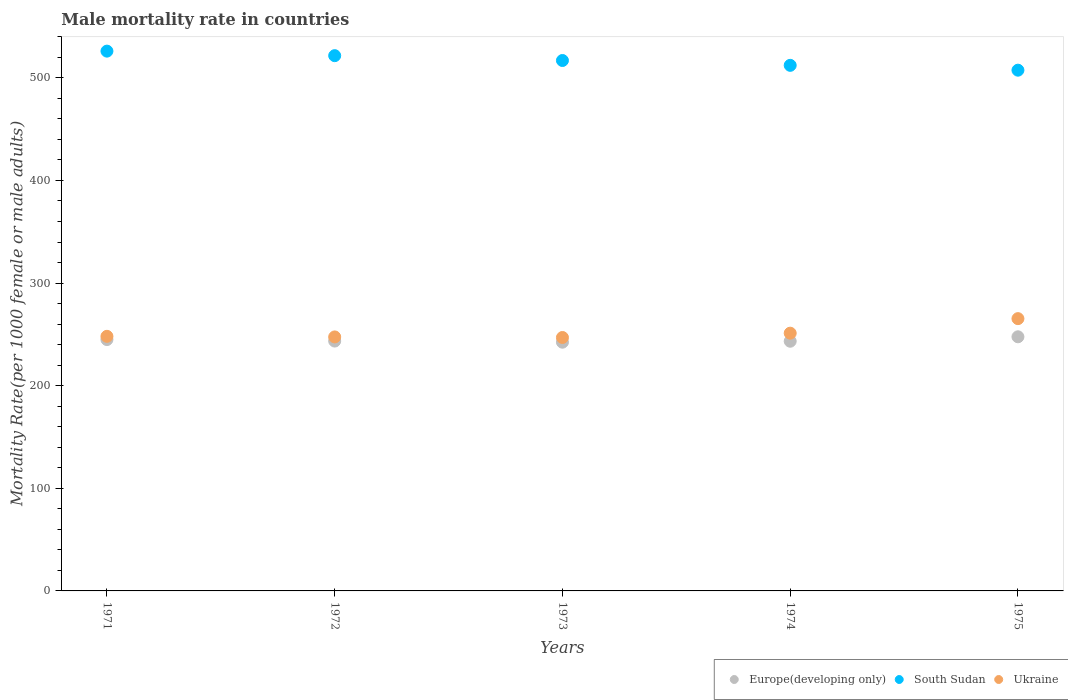How many different coloured dotlines are there?
Ensure brevity in your answer.  3. What is the male mortality rate in Ukraine in 1972?
Your response must be concise. 247.51. Across all years, what is the maximum male mortality rate in Europe(developing only)?
Your answer should be very brief. 247.64. Across all years, what is the minimum male mortality rate in South Sudan?
Provide a short and direct response. 507.44. In which year was the male mortality rate in Europe(developing only) maximum?
Offer a terse response. 1975. In which year was the male mortality rate in South Sudan minimum?
Ensure brevity in your answer.  1975. What is the total male mortality rate in Ukraine in the graph?
Offer a very short reply. 1259.04. What is the difference between the male mortality rate in Europe(developing only) in 1971 and that in 1972?
Your answer should be very brief. 1.46. What is the difference between the male mortality rate in Europe(developing only) in 1975 and the male mortality rate in Ukraine in 1974?
Offer a very short reply. -3.52. What is the average male mortality rate in Europe(developing only) per year?
Your answer should be compact. 244.35. In the year 1971, what is the difference between the male mortality rate in South Sudan and male mortality rate in Ukraine?
Give a very brief answer. 277.92. What is the ratio of the male mortality rate in Europe(developing only) in 1972 to that in 1974?
Offer a terse response. 1. Is the male mortality rate in South Sudan in 1971 less than that in 1973?
Provide a succinct answer. No. Is the difference between the male mortality rate in South Sudan in 1973 and 1974 greater than the difference between the male mortality rate in Ukraine in 1973 and 1974?
Keep it short and to the point. Yes. What is the difference between the highest and the second highest male mortality rate in Europe(developing only)?
Keep it short and to the point. 2.69. What is the difference between the highest and the lowest male mortality rate in Ukraine?
Make the answer very short. 18.38. In how many years, is the male mortality rate in Ukraine greater than the average male mortality rate in Ukraine taken over all years?
Ensure brevity in your answer.  1. Is the male mortality rate in Europe(developing only) strictly greater than the male mortality rate in South Sudan over the years?
Your response must be concise. No. How many dotlines are there?
Keep it short and to the point. 3. Are the values on the major ticks of Y-axis written in scientific E-notation?
Keep it short and to the point. No. Does the graph contain any zero values?
Your answer should be very brief. No. How many legend labels are there?
Provide a short and direct response. 3. How are the legend labels stacked?
Give a very brief answer. Horizontal. What is the title of the graph?
Your answer should be compact. Male mortality rate in countries. Does "Libya" appear as one of the legend labels in the graph?
Ensure brevity in your answer.  No. What is the label or title of the Y-axis?
Provide a short and direct response. Mortality Rate(per 1000 female or male adults). What is the Mortality Rate(per 1000 female or male adults) of Europe(developing only) in 1971?
Ensure brevity in your answer.  244.95. What is the Mortality Rate(per 1000 female or male adults) in South Sudan in 1971?
Give a very brief answer. 526.01. What is the Mortality Rate(per 1000 female or male adults) of Ukraine in 1971?
Keep it short and to the point. 248.09. What is the Mortality Rate(per 1000 female or male adults) of Europe(developing only) in 1972?
Ensure brevity in your answer.  243.49. What is the Mortality Rate(per 1000 female or male adults) of South Sudan in 1972?
Ensure brevity in your answer.  521.59. What is the Mortality Rate(per 1000 female or male adults) of Ukraine in 1972?
Provide a succinct answer. 247.51. What is the Mortality Rate(per 1000 female or male adults) in Europe(developing only) in 1973?
Offer a very short reply. 242.38. What is the Mortality Rate(per 1000 female or male adults) of South Sudan in 1973?
Offer a very short reply. 516.87. What is the Mortality Rate(per 1000 female or male adults) in Ukraine in 1973?
Keep it short and to the point. 246.95. What is the Mortality Rate(per 1000 female or male adults) of Europe(developing only) in 1974?
Provide a short and direct response. 243.32. What is the Mortality Rate(per 1000 female or male adults) in South Sudan in 1974?
Your response must be concise. 512.16. What is the Mortality Rate(per 1000 female or male adults) in Ukraine in 1974?
Offer a very short reply. 251.16. What is the Mortality Rate(per 1000 female or male adults) in Europe(developing only) in 1975?
Give a very brief answer. 247.64. What is the Mortality Rate(per 1000 female or male adults) in South Sudan in 1975?
Your response must be concise. 507.44. What is the Mortality Rate(per 1000 female or male adults) in Ukraine in 1975?
Offer a terse response. 265.33. Across all years, what is the maximum Mortality Rate(per 1000 female or male adults) of Europe(developing only)?
Offer a terse response. 247.64. Across all years, what is the maximum Mortality Rate(per 1000 female or male adults) in South Sudan?
Keep it short and to the point. 526.01. Across all years, what is the maximum Mortality Rate(per 1000 female or male adults) in Ukraine?
Your response must be concise. 265.33. Across all years, what is the minimum Mortality Rate(per 1000 female or male adults) in Europe(developing only)?
Provide a short and direct response. 242.38. Across all years, what is the minimum Mortality Rate(per 1000 female or male adults) of South Sudan?
Your answer should be very brief. 507.44. Across all years, what is the minimum Mortality Rate(per 1000 female or male adults) in Ukraine?
Keep it short and to the point. 246.95. What is the total Mortality Rate(per 1000 female or male adults) in Europe(developing only) in the graph?
Offer a very short reply. 1221.77. What is the total Mortality Rate(per 1000 female or male adults) of South Sudan in the graph?
Provide a short and direct response. 2584.07. What is the total Mortality Rate(per 1000 female or male adults) in Ukraine in the graph?
Your answer should be very brief. 1259.04. What is the difference between the Mortality Rate(per 1000 female or male adults) in Europe(developing only) in 1971 and that in 1972?
Your answer should be compact. 1.46. What is the difference between the Mortality Rate(per 1000 female or male adults) in South Sudan in 1971 and that in 1972?
Ensure brevity in your answer.  4.42. What is the difference between the Mortality Rate(per 1000 female or male adults) of Ukraine in 1971 and that in 1972?
Provide a short and direct response. 0.58. What is the difference between the Mortality Rate(per 1000 female or male adults) in Europe(developing only) in 1971 and that in 1973?
Keep it short and to the point. 2.57. What is the difference between the Mortality Rate(per 1000 female or male adults) in South Sudan in 1971 and that in 1973?
Offer a very short reply. 9.13. What is the difference between the Mortality Rate(per 1000 female or male adults) of Ukraine in 1971 and that in 1973?
Offer a very short reply. 1.14. What is the difference between the Mortality Rate(per 1000 female or male adults) in Europe(developing only) in 1971 and that in 1974?
Your response must be concise. 1.63. What is the difference between the Mortality Rate(per 1000 female or male adults) of South Sudan in 1971 and that in 1974?
Give a very brief answer. 13.85. What is the difference between the Mortality Rate(per 1000 female or male adults) in Ukraine in 1971 and that in 1974?
Give a very brief answer. -3.06. What is the difference between the Mortality Rate(per 1000 female or male adults) of Europe(developing only) in 1971 and that in 1975?
Offer a very short reply. -2.69. What is the difference between the Mortality Rate(per 1000 female or male adults) of South Sudan in 1971 and that in 1975?
Your answer should be very brief. 18.57. What is the difference between the Mortality Rate(per 1000 female or male adults) of Ukraine in 1971 and that in 1975?
Your answer should be very brief. -17.24. What is the difference between the Mortality Rate(per 1000 female or male adults) in Europe(developing only) in 1972 and that in 1973?
Ensure brevity in your answer.  1.11. What is the difference between the Mortality Rate(per 1000 female or male adults) in South Sudan in 1972 and that in 1973?
Ensure brevity in your answer.  4.72. What is the difference between the Mortality Rate(per 1000 female or male adults) in Ukraine in 1972 and that in 1973?
Your response must be concise. 0.56. What is the difference between the Mortality Rate(per 1000 female or male adults) in Europe(developing only) in 1972 and that in 1974?
Your answer should be compact. 0.17. What is the difference between the Mortality Rate(per 1000 female or male adults) in South Sudan in 1972 and that in 1974?
Ensure brevity in your answer.  9.43. What is the difference between the Mortality Rate(per 1000 female or male adults) of Ukraine in 1972 and that in 1974?
Make the answer very short. -3.65. What is the difference between the Mortality Rate(per 1000 female or male adults) in Europe(developing only) in 1972 and that in 1975?
Offer a terse response. -4.15. What is the difference between the Mortality Rate(per 1000 female or male adults) of South Sudan in 1972 and that in 1975?
Your answer should be compact. 14.15. What is the difference between the Mortality Rate(per 1000 female or male adults) of Ukraine in 1972 and that in 1975?
Your answer should be very brief. -17.82. What is the difference between the Mortality Rate(per 1000 female or male adults) in Europe(developing only) in 1973 and that in 1974?
Ensure brevity in your answer.  -0.93. What is the difference between the Mortality Rate(per 1000 female or male adults) in South Sudan in 1973 and that in 1974?
Ensure brevity in your answer.  4.72. What is the difference between the Mortality Rate(per 1000 female or male adults) in Ukraine in 1973 and that in 1974?
Your answer should be very brief. -4.21. What is the difference between the Mortality Rate(per 1000 female or male adults) of Europe(developing only) in 1973 and that in 1975?
Give a very brief answer. -5.25. What is the difference between the Mortality Rate(per 1000 female or male adults) in South Sudan in 1973 and that in 1975?
Your answer should be very brief. 9.43. What is the difference between the Mortality Rate(per 1000 female or male adults) in Ukraine in 1973 and that in 1975?
Your response must be concise. -18.38. What is the difference between the Mortality Rate(per 1000 female or male adults) in Europe(developing only) in 1974 and that in 1975?
Offer a very short reply. -4.32. What is the difference between the Mortality Rate(per 1000 female or male adults) of South Sudan in 1974 and that in 1975?
Provide a succinct answer. 4.72. What is the difference between the Mortality Rate(per 1000 female or male adults) of Ukraine in 1974 and that in 1975?
Your answer should be compact. -14.18. What is the difference between the Mortality Rate(per 1000 female or male adults) of Europe(developing only) in 1971 and the Mortality Rate(per 1000 female or male adults) of South Sudan in 1972?
Your answer should be very brief. -276.64. What is the difference between the Mortality Rate(per 1000 female or male adults) in Europe(developing only) in 1971 and the Mortality Rate(per 1000 female or male adults) in Ukraine in 1972?
Keep it short and to the point. -2.56. What is the difference between the Mortality Rate(per 1000 female or male adults) of South Sudan in 1971 and the Mortality Rate(per 1000 female or male adults) of Ukraine in 1972?
Keep it short and to the point. 278.5. What is the difference between the Mortality Rate(per 1000 female or male adults) of Europe(developing only) in 1971 and the Mortality Rate(per 1000 female or male adults) of South Sudan in 1973?
Offer a very short reply. -271.93. What is the difference between the Mortality Rate(per 1000 female or male adults) of Europe(developing only) in 1971 and the Mortality Rate(per 1000 female or male adults) of Ukraine in 1973?
Your answer should be very brief. -2. What is the difference between the Mortality Rate(per 1000 female or male adults) in South Sudan in 1971 and the Mortality Rate(per 1000 female or male adults) in Ukraine in 1973?
Offer a terse response. 279.06. What is the difference between the Mortality Rate(per 1000 female or male adults) in Europe(developing only) in 1971 and the Mortality Rate(per 1000 female or male adults) in South Sudan in 1974?
Keep it short and to the point. -267.21. What is the difference between the Mortality Rate(per 1000 female or male adults) of Europe(developing only) in 1971 and the Mortality Rate(per 1000 female or male adults) of Ukraine in 1974?
Ensure brevity in your answer.  -6.21. What is the difference between the Mortality Rate(per 1000 female or male adults) in South Sudan in 1971 and the Mortality Rate(per 1000 female or male adults) in Ukraine in 1974?
Keep it short and to the point. 274.85. What is the difference between the Mortality Rate(per 1000 female or male adults) of Europe(developing only) in 1971 and the Mortality Rate(per 1000 female or male adults) of South Sudan in 1975?
Offer a very short reply. -262.49. What is the difference between the Mortality Rate(per 1000 female or male adults) in Europe(developing only) in 1971 and the Mortality Rate(per 1000 female or male adults) in Ukraine in 1975?
Give a very brief answer. -20.39. What is the difference between the Mortality Rate(per 1000 female or male adults) in South Sudan in 1971 and the Mortality Rate(per 1000 female or male adults) in Ukraine in 1975?
Keep it short and to the point. 260.68. What is the difference between the Mortality Rate(per 1000 female or male adults) in Europe(developing only) in 1972 and the Mortality Rate(per 1000 female or male adults) in South Sudan in 1973?
Provide a succinct answer. -273.38. What is the difference between the Mortality Rate(per 1000 female or male adults) in Europe(developing only) in 1972 and the Mortality Rate(per 1000 female or male adults) in Ukraine in 1973?
Offer a very short reply. -3.46. What is the difference between the Mortality Rate(per 1000 female or male adults) in South Sudan in 1972 and the Mortality Rate(per 1000 female or male adults) in Ukraine in 1973?
Your response must be concise. 274.64. What is the difference between the Mortality Rate(per 1000 female or male adults) in Europe(developing only) in 1972 and the Mortality Rate(per 1000 female or male adults) in South Sudan in 1974?
Make the answer very short. -268.67. What is the difference between the Mortality Rate(per 1000 female or male adults) in Europe(developing only) in 1972 and the Mortality Rate(per 1000 female or male adults) in Ukraine in 1974?
Provide a short and direct response. -7.67. What is the difference between the Mortality Rate(per 1000 female or male adults) in South Sudan in 1972 and the Mortality Rate(per 1000 female or male adults) in Ukraine in 1974?
Provide a short and direct response. 270.44. What is the difference between the Mortality Rate(per 1000 female or male adults) of Europe(developing only) in 1972 and the Mortality Rate(per 1000 female or male adults) of South Sudan in 1975?
Give a very brief answer. -263.95. What is the difference between the Mortality Rate(per 1000 female or male adults) of Europe(developing only) in 1972 and the Mortality Rate(per 1000 female or male adults) of Ukraine in 1975?
Your answer should be very brief. -21.84. What is the difference between the Mortality Rate(per 1000 female or male adults) of South Sudan in 1972 and the Mortality Rate(per 1000 female or male adults) of Ukraine in 1975?
Make the answer very short. 256.26. What is the difference between the Mortality Rate(per 1000 female or male adults) of Europe(developing only) in 1973 and the Mortality Rate(per 1000 female or male adults) of South Sudan in 1974?
Provide a short and direct response. -269.77. What is the difference between the Mortality Rate(per 1000 female or male adults) of Europe(developing only) in 1973 and the Mortality Rate(per 1000 female or male adults) of Ukraine in 1974?
Make the answer very short. -8.77. What is the difference between the Mortality Rate(per 1000 female or male adults) of South Sudan in 1973 and the Mortality Rate(per 1000 female or male adults) of Ukraine in 1974?
Your answer should be very brief. 265.72. What is the difference between the Mortality Rate(per 1000 female or male adults) in Europe(developing only) in 1973 and the Mortality Rate(per 1000 female or male adults) in South Sudan in 1975?
Your response must be concise. -265.06. What is the difference between the Mortality Rate(per 1000 female or male adults) in Europe(developing only) in 1973 and the Mortality Rate(per 1000 female or male adults) in Ukraine in 1975?
Make the answer very short. -22.95. What is the difference between the Mortality Rate(per 1000 female or male adults) of South Sudan in 1973 and the Mortality Rate(per 1000 female or male adults) of Ukraine in 1975?
Make the answer very short. 251.54. What is the difference between the Mortality Rate(per 1000 female or male adults) of Europe(developing only) in 1974 and the Mortality Rate(per 1000 female or male adults) of South Sudan in 1975?
Provide a short and direct response. -264.12. What is the difference between the Mortality Rate(per 1000 female or male adults) of Europe(developing only) in 1974 and the Mortality Rate(per 1000 female or male adults) of Ukraine in 1975?
Provide a succinct answer. -22.02. What is the difference between the Mortality Rate(per 1000 female or male adults) of South Sudan in 1974 and the Mortality Rate(per 1000 female or male adults) of Ukraine in 1975?
Ensure brevity in your answer.  246.82. What is the average Mortality Rate(per 1000 female or male adults) in Europe(developing only) per year?
Your answer should be very brief. 244.35. What is the average Mortality Rate(per 1000 female or male adults) in South Sudan per year?
Provide a short and direct response. 516.81. What is the average Mortality Rate(per 1000 female or male adults) in Ukraine per year?
Offer a very short reply. 251.81. In the year 1971, what is the difference between the Mortality Rate(per 1000 female or male adults) of Europe(developing only) and Mortality Rate(per 1000 female or male adults) of South Sudan?
Provide a succinct answer. -281.06. In the year 1971, what is the difference between the Mortality Rate(per 1000 female or male adults) of Europe(developing only) and Mortality Rate(per 1000 female or male adults) of Ukraine?
Your answer should be very brief. -3.15. In the year 1971, what is the difference between the Mortality Rate(per 1000 female or male adults) in South Sudan and Mortality Rate(per 1000 female or male adults) in Ukraine?
Give a very brief answer. 277.92. In the year 1972, what is the difference between the Mortality Rate(per 1000 female or male adults) in Europe(developing only) and Mortality Rate(per 1000 female or male adults) in South Sudan?
Provide a succinct answer. -278.1. In the year 1972, what is the difference between the Mortality Rate(per 1000 female or male adults) in Europe(developing only) and Mortality Rate(per 1000 female or male adults) in Ukraine?
Offer a terse response. -4.02. In the year 1972, what is the difference between the Mortality Rate(per 1000 female or male adults) in South Sudan and Mortality Rate(per 1000 female or male adults) in Ukraine?
Your answer should be very brief. 274.08. In the year 1973, what is the difference between the Mortality Rate(per 1000 female or male adults) of Europe(developing only) and Mortality Rate(per 1000 female or male adults) of South Sudan?
Your answer should be very brief. -274.49. In the year 1973, what is the difference between the Mortality Rate(per 1000 female or male adults) in Europe(developing only) and Mortality Rate(per 1000 female or male adults) in Ukraine?
Offer a terse response. -4.57. In the year 1973, what is the difference between the Mortality Rate(per 1000 female or male adults) in South Sudan and Mortality Rate(per 1000 female or male adults) in Ukraine?
Make the answer very short. 269.92. In the year 1974, what is the difference between the Mortality Rate(per 1000 female or male adults) in Europe(developing only) and Mortality Rate(per 1000 female or male adults) in South Sudan?
Give a very brief answer. -268.84. In the year 1974, what is the difference between the Mortality Rate(per 1000 female or male adults) of Europe(developing only) and Mortality Rate(per 1000 female or male adults) of Ukraine?
Your answer should be very brief. -7.84. In the year 1974, what is the difference between the Mortality Rate(per 1000 female or male adults) in South Sudan and Mortality Rate(per 1000 female or male adults) in Ukraine?
Offer a terse response. 261. In the year 1975, what is the difference between the Mortality Rate(per 1000 female or male adults) in Europe(developing only) and Mortality Rate(per 1000 female or male adults) in South Sudan?
Offer a terse response. -259.8. In the year 1975, what is the difference between the Mortality Rate(per 1000 female or male adults) in Europe(developing only) and Mortality Rate(per 1000 female or male adults) in Ukraine?
Your response must be concise. -17.7. In the year 1975, what is the difference between the Mortality Rate(per 1000 female or male adults) of South Sudan and Mortality Rate(per 1000 female or male adults) of Ukraine?
Ensure brevity in your answer.  242.11. What is the ratio of the Mortality Rate(per 1000 female or male adults) in Europe(developing only) in 1971 to that in 1972?
Make the answer very short. 1.01. What is the ratio of the Mortality Rate(per 1000 female or male adults) in South Sudan in 1971 to that in 1972?
Provide a succinct answer. 1.01. What is the ratio of the Mortality Rate(per 1000 female or male adults) of Europe(developing only) in 1971 to that in 1973?
Offer a terse response. 1.01. What is the ratio of the Mortality Rate(per 1000 female or male adults) of South Sudan in 1971 to that in 1973?
Offer a very short reply. 1.02. What is the ratio of the Mortality Rate(per 1000 female or male adults) in South Sudan in 1971 to that in 1975?
Ensure brevity in your answer.  1.04. What is the ratio of the Mortality Rate(per 1000 female or male adults) of Ukraine in 1971 to that in 1975?
Make the answer very short. 0.94. What is the ratio of the Mortality Rate(per 1000 female or male adults) in South Sudan in 1972 to that in 1973?
Give a very brief answer. 1.01. What is the ratio of the Mortality Rate(per 1000 female or male adults) in Europe(developing only) in 1972 to that in 1974?
Provide a short and direct response. 1. What is the ratio of the Mortality Rate(per 1000 female or male adults) of South Sudan in 1972 to that in 1974?
Offer a very short reply. 1.02. What is the ratio of the Mortality Rate(per 1000 female or male adults) of Ukraine in 1972 to that in 1974?
Keep it short and to the point. 0.99. What is the ratio of the Mortality Rate(per 1000 female or male adults) in Europe(developing only) in 1972 to that in 1975?
Provide a short and direct response. 0.98. What is the ratio of the Mortality Rate(per 1000 female or male adults) in South Sudan in 1972 to that in 1975?
Provide a short and direct response. 1.03. What is the ratio of the Mortality Rate(per 1000 female or male adults) in Ukraine in 1972 to that in 1975?
Provide a short and direct response. 0.93. What is the ratio of the Mortality Rate(per 1000 female or male adults) in South Sudan in 1973 to that in 1974?
Offer a terse response. 1.01. What is the ratio of the Mortality Rate(per 1000 female or male adults) in Ukraine in 1973 to that in 1974?
Provide a succinct answer. 0.98. What is the ratio of the Mortality Rate(per 1000 female or male adults) of Europe(developing only) in 1973 to that in 1975?
Offer a terse response. 0.98. What is the ratio of the Mortality Rate(per 1000 female or male adults) in South Sudan in 1973 to that in 1975?
Your response must be concise. 1.02. What is the ratio of the Mortality Rate(per 1000 female or male adults) in Ukraine in 1973 to that in 1975?
Your answer should be very brief. 0.93. What is the ratio of the Mortality Rate(per 1000 female or male adults) in Europe(developing only) in 1974 to that in 1975?
Your answer should be very brief. 0.98. What is the ratio of the Mortality Rate(per 1000 female or male adults) in South Sudan in 1974 to that in 1975?
Your answer should be very brief. 1.01. What is the ratio of the Mortality Rate(per 1000 female or male adults) in Ukraine in 1974 to that in 1975?
Make the answer very short. 0.95. What is the difference between the highest and the second highest Mortality Rate(per 1000 female or male adults) of Europe(developing only)?
Provide a short and direct response. 2.69. What is the difference between the highest and the second highest Mortality Rate(per 1000 female or male adults) in South Sudan?
Provide a succinct answer. 4.42. What is the difference between the highest and the second highest Mortality Rate(per 1000 female or male adults) of Ukraine?
Offer a very short reply. 14.18. What is the difference between the highest and the lowest Mortality Rate(per 1000 female or male adults) of Europe(developing only)?
Your answer should be compact. 5.25. What is the difference between the highest and the lowest Mortality Rate(per 1000 female or male adults) of South Sudan?
Provide a short and direct response. 18.57. What is the difference between the highest and the lowest Mortality Rate(per 1000 female or male adults) in Ukraine?
Keep it short and to the point. 18.38. 